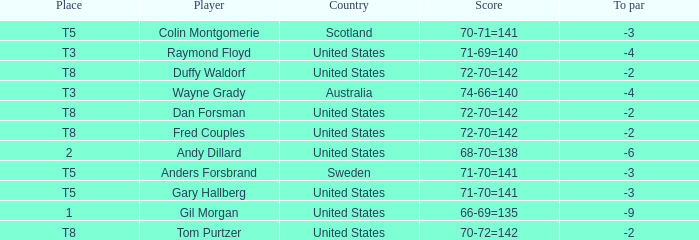What is the T8 Place Player? Fred Couples, Dan Forsman, Tom Purtzer, Duffy Waldorf. 